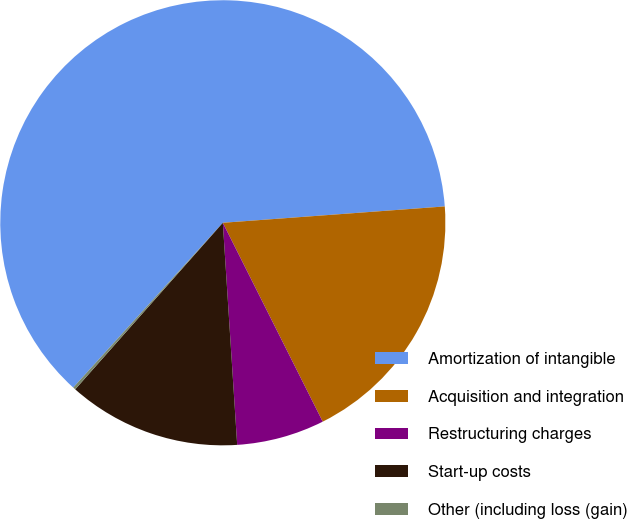Convert chart to OTSL. <chart><loc_0><loc_0><loc_500><loc_500><pie_chart><fcel>Amortization of intangible<fcel>Acquisition and integration<fcel>Restructuring charges<fcel>Start-up costs<fcel>Other (including loss (gain)<nl><fcel>62.09%<fcel>18.76%<fcel>6.38%<fcel>12.57%<fcel>0.19%<nl></chart> 